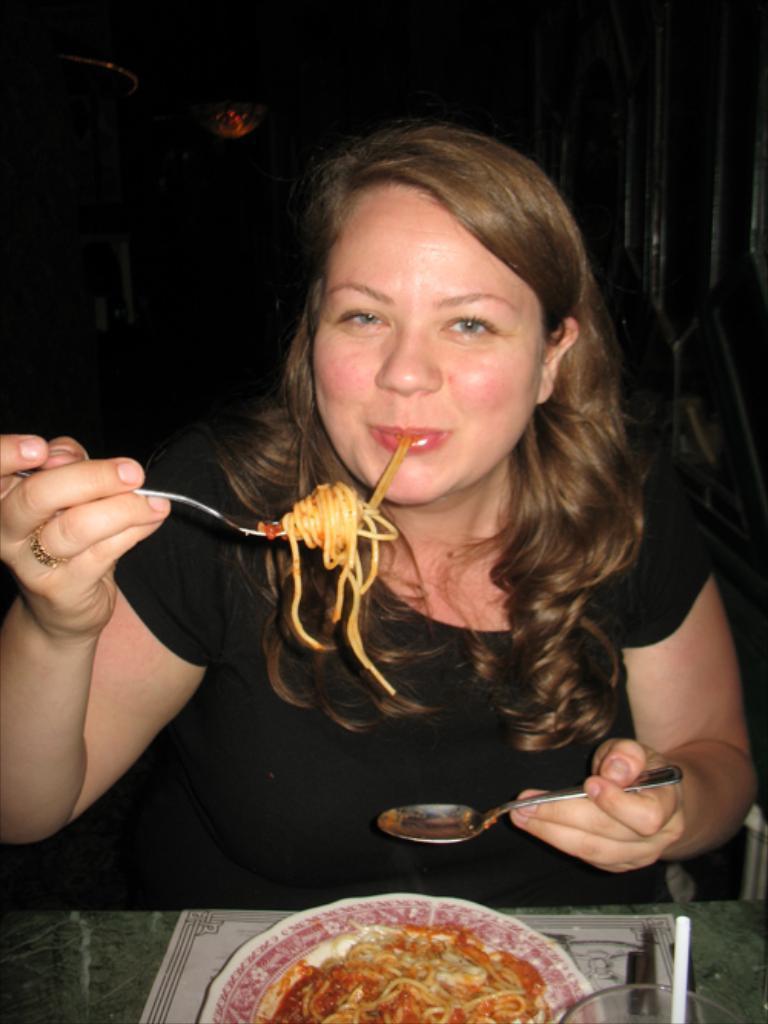Can you describe this image briefly? In this image the background is dark. At the bottom of the image there is a table with a paper, a glass and a plate with noodles on it. In the middle of the image a woman is sitting and she is holding a spoon in her hands and having noodles. 